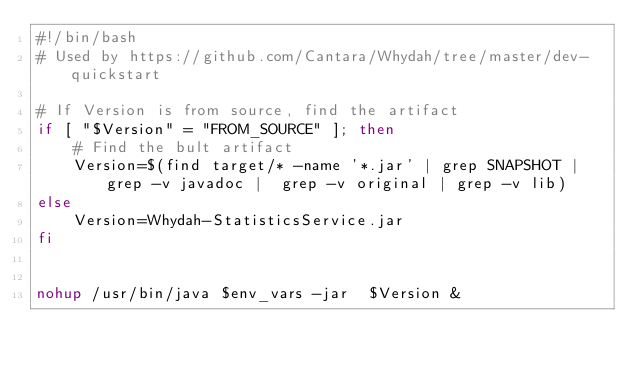Convert code to text. <code><loc_0><loc_0><loc_500><loc_500><_Bash_>#!/bin/bash
# Used by https://github.com/Cantara/Whydah/tree/master/dev-quickstart

# If Version is from source, find the artifact
if [ "$Version" = "FROM_SOURCE" ]; then
    # Find the bult artifact
    Version=$(find target/* -name '*.jar' | grep SNAPSHOT | grep -v javadoc |  grep -v original | grep -v lib)
else
    Version=Whydah-StatisticsService.jar
fi


nohup /usr/bin/java $env_vars -jar  $Version &
</code> 